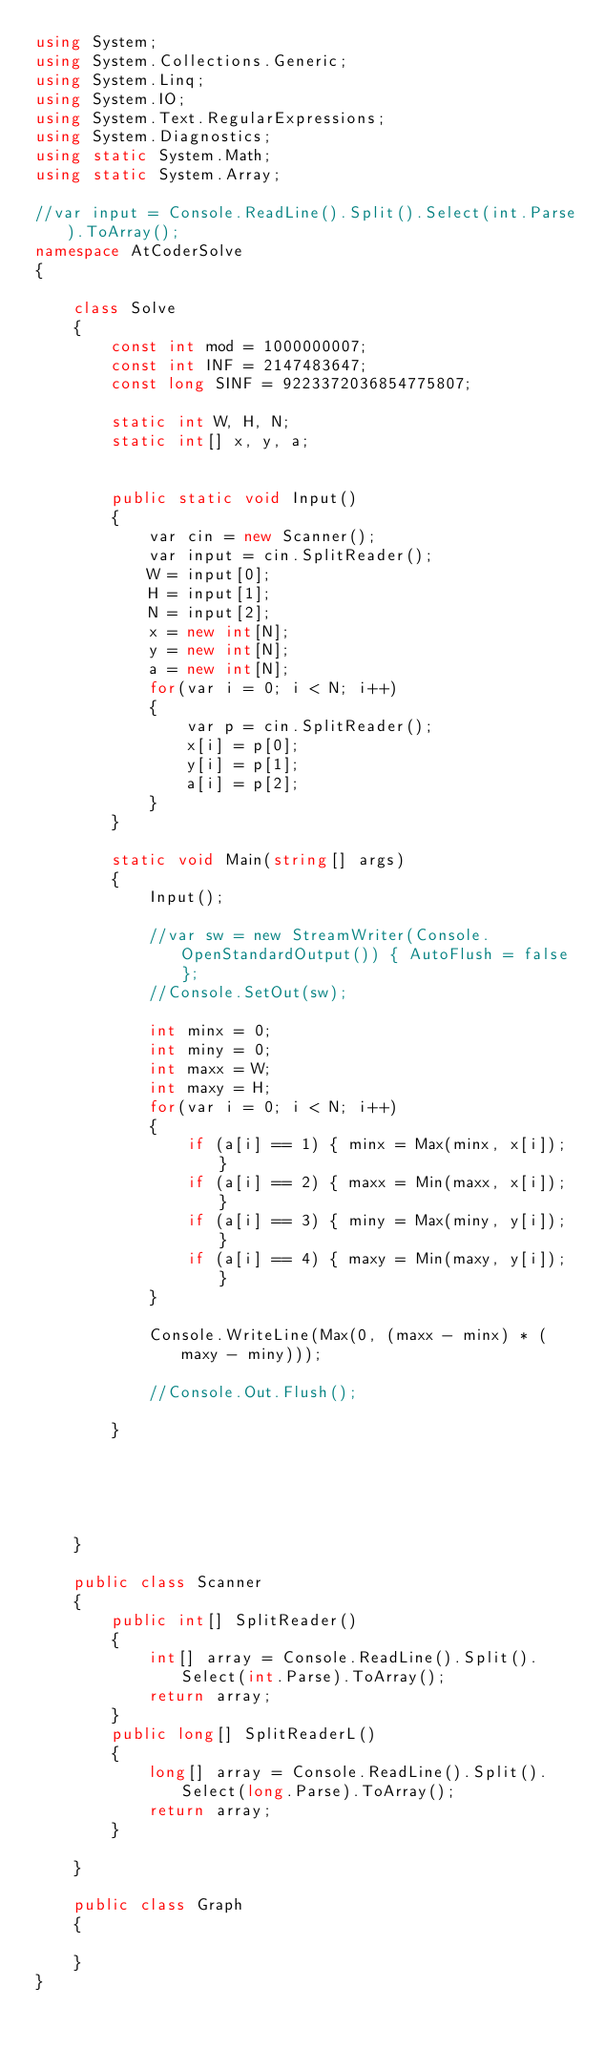Convert code to text. <code><loc_0><loc_0><loc_500><loc_500><_C#_>using System;
using System.Collections.Generic;
using System.Linq;
using System.IO;
using System.Text.RegularExpressions;
using System.Diagnostics;
using static System.Math;
using static System.Array;

//var input = Console.ReadLine().Split().Select(int.Parse).ToArray();
namespace AtCoderSolve
{

    class Solve
    {
        const int mod = 1000000007;
        const int INF = 2147483647;
        const long SINF = 9223372036854775807;

        static int W, H, N;
        static int[] x, y, a;
        

        public static void Input()
        {
            var cin = new Scanner();
            var input = cin.SplitReader();
            W = input[0];
            H = input[1];
            N = input[2];
            x = new int[N];
            y = new int[N];
            a = new int[N];
            for(var i = 0; i < N; i++)
            {
                var p = cin.SplitReader();
                x[i] = p[0];
                y[i] = p[1];
                a[i] = p[2];
            }
        }

        static void Main(string[] args)
        {
            Input();

            //var sw = new StreamWriter(Console.OpenStandardOutput()) { AutoFlush = false };
            //Console.SetOut(sw);

            int minx = 0;
            int miny = 0;
            int maxx = W;
            int maxy = H;
            for(var i = 0; i < N; i++)
            {
                if (a[i] == 1) { minx = Max(minx, x[i]); }
                if (a[i] == 2) { maxx = Min(maxx, x[i]); }
                if (a[i] == 3) { miny = Max(miny, y[i]); }
                if (a[i] == 4) { maxy = Min(maxy, y[i]); }
            }

            Console.WriteLine(Max(0, (maxx - minx) * (maxy - miny)));

            //Console.Out.Flush();

        }





    }

    public class Scanner
    {
        public int[] SplitReader()
        {
            int[] array = Console.ReadLine().Split().Select(int.Parse).ToArray();
            return array;
        }
        public long[] SplitReaderL()
        {
            long[] array = Console.ReadLine().Split().Select(long.Parse).ToArray();
            return array;
        }

    }

    public class Graph
    {
        
    }
}

    

</code> 